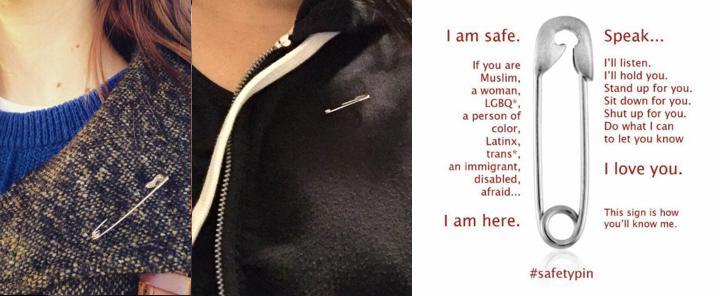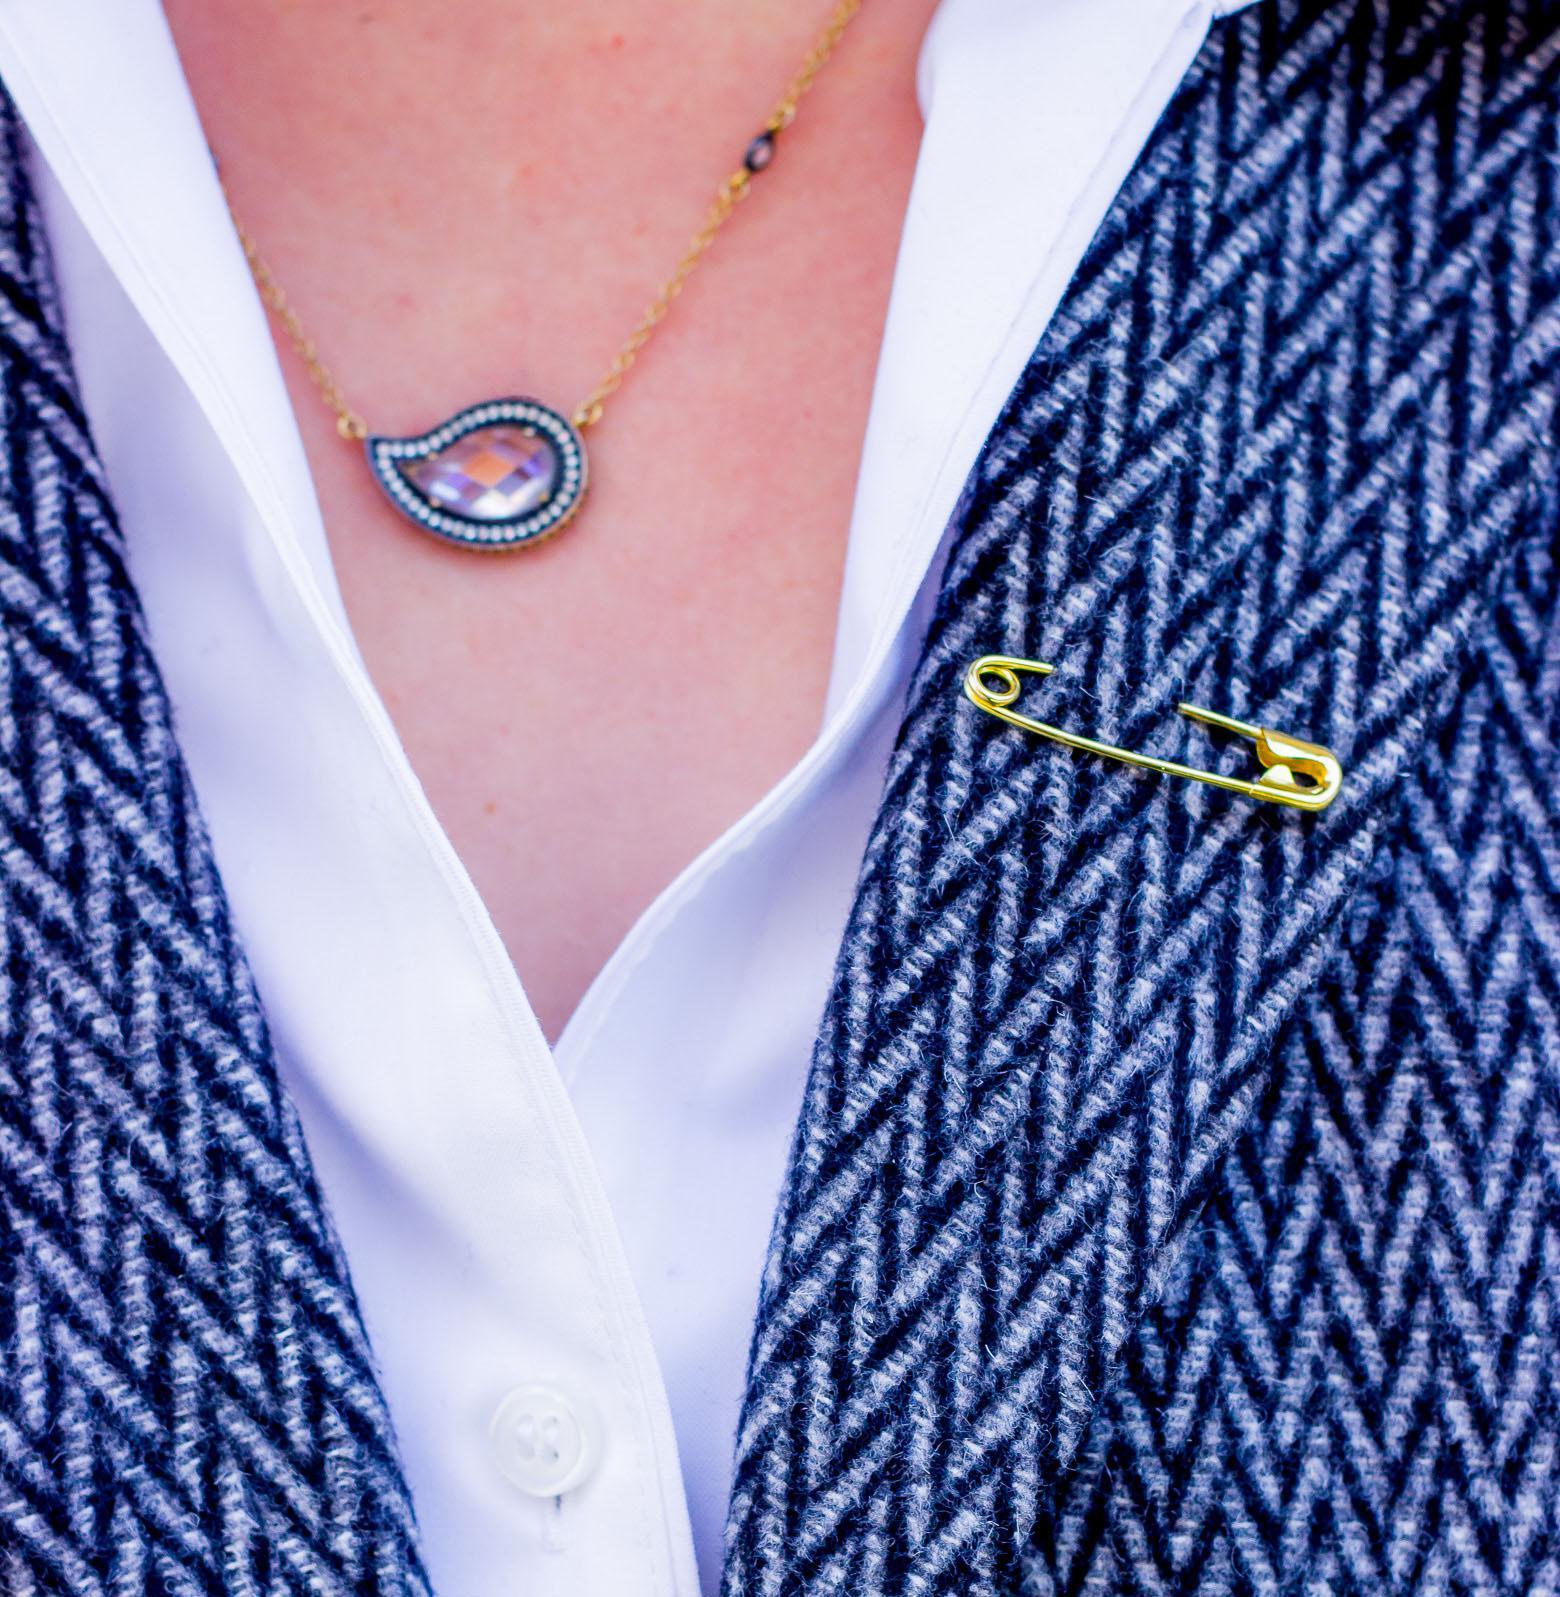The first image is the image on the left, the second image is the image on the right. Considering the images on both sides, is "There are three people saving the world by wearing safety pins." valid? Answer yes or no. Yes. The first image is the image on the left, the second image is the image on the right. Examine the images to the left and right. Is the description "Each image shows a safety pin attached to someone's shirt, though no part of their head is visible." accurate? Answer yes or no. Yes. 